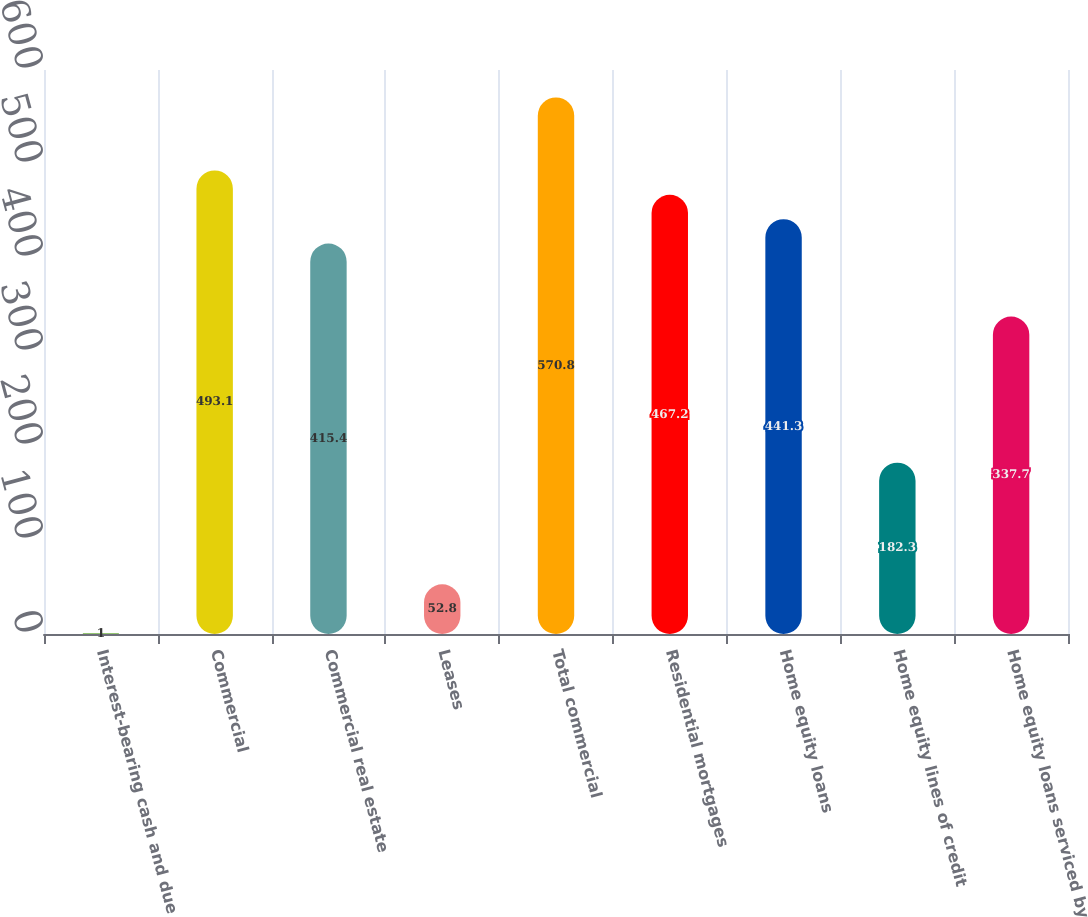Convert chart. <chart><loc_0><loc_0><loc_500><loc_500><bar_chart><fcel>Interest-bearing cash and due<fcel>Commercial<fcel>Commercial real estate<fcel>Leases<fcel>Total commercial<fcel>Residential mortgages<fcel>Home equity loans<fcel>Home equity lines of credit<fcel>Home equity loans serviced by<nl><fcel>1<fcel>493.1<fcel>415.4<fcel>52.8<fcel>570.8<fcel>467.2<fcel>441.3<fcel>182.3<fcel>337.7<nl></chart> 